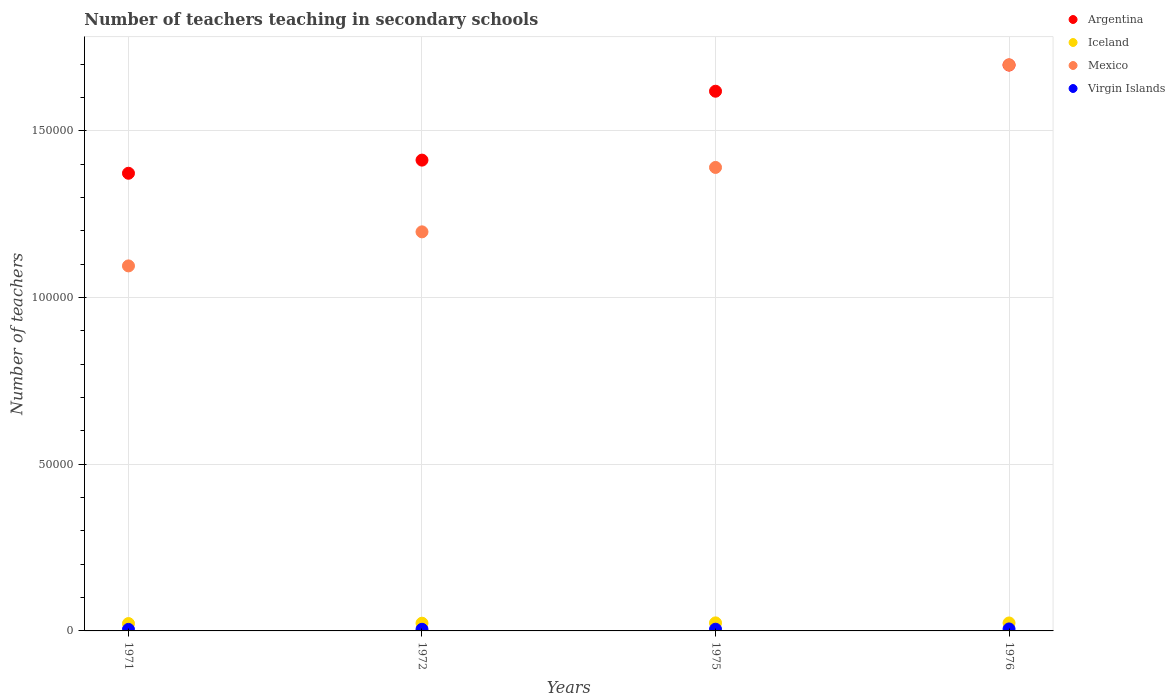Is the number of dotlines equal to the number of legend labels?
Offer a very short reply. Yes. What is the number of teachers teaching in secondary schools in Mexico in 1975?
Make the answer very short. 1.39e+05. Across all years, what is the maximum number of teachers teaching in secondary schools in Mexico?
Offer a very short reply. 1.70e+05. Across all years, what is the minimum number of teachers teaching in secondary schools in Iceland?
Your answer should be very brief. 2207. In which year was the number of teachers teaching in secondary schools in Mexico maximum?
Your answer should be very brief. 1976. What is the total number of teachers teaching in secondary schools in Iceland in the graph?
Your answer should be very brief. 9325. What is the difference between the number of teachers teaching in secondary schools in Iceland in 1972 and that in 1975?
Provide a succinct answer. -95. What is the difference between the number of teachers teaching in secondary schools in Iceland in 1971 and the number of teachers teaching in secondary schools in Virgin Islands in 1972?
Provide a short and direct response. 1720. What is the average number of teachers teaching in secondary schools in Iceland per year?
Your answer should be compact. 2331.25. In the year 1975, what is the difference between the number of teachers teaching in secondary schools in Argentina and number of teachers teaching in secondary schools in Mexico?
Give a very brief answer. 2.29e+04. In how many years, is the number of teachers teaching in secondary schools in Mexico greater than 80000?
Provide a succinct answer. 4. What is the ratio of the number of teachers teaching in secondary schools in Argentina in 1971 to that in 1975?
Offer a terse response. 0.85. Is the number of teachers teaching in secondary schools in Argentina in 1972 less than that in 1975?
Offer a terse response. Yes. Is the difference between the number of teachers teaching in secondary schools in Argentina in 1975 and 1976 greater than the difference between the number of teachers teaching in secondary schools in Mexico in 1975 and 1976?
Your answer should be compact. Yes. What is the difference between the highest and the lowest number of teachers teaching in secondary schools in Virgin Islands?
Your response must be concise. 132. In how many years, is the number of teachers teaching in secondary schools in Mexico greater than the average number of teachers teaching in secondary schools in Mexico taken over all years?
Ensure brevity in your answer.  2. Is the sum of the number of teachers teaching in secondary schools in Argentina in 1971 and 1972 greater than the maximum number of teachers teaching in secondary schools in Iceland across all years?
Make the answer very short. Yes. Is it the case that in every year, the sum of the number of teachers teaching in secondary schools in Argentina and number of teachers teaching in secondary schools in Iceland  is greater than the number of teachers teaching in secondary schools in Virgin Islands?
Your response must be concise. Yes. Does the number of teachers teaching in secondary schools in Argentina monotonically increase over the years?
Keep it short and to the point. Yes. How many dotlines are there?
Your response must be concise. 4. What is the difference between two consecutive major ticks on the Y-axis?
Offer a terse response. 5.00e+04. Are the values on the major ticks of Y-axis written in scientific E-notation?
Ensure brevity in your answer.  No. Does the graph contain any zero values?
Ensure brevity in your answer.  No. What is the title of the graph?
Provide a succinct answer. Number of teachers teaching in secondary schools. Does "Ecuador" appear as one of the legend labels in the graph?
Make the answer very short. No. What is the label or title of the X-axis?
Make the answer very short. Years. What is the label or title of the Y-axis?
Keep it short and to the point. Number of teachers. What is the Number of teachers of Argentina in 1971?
Your answer should be very brief. 1.37e+05. What is the Number of teachers of Iceland in 1971?
Make the answer very short. 2207. What is the Number of teachers in Mexico in 1971?
Your answer should be compact. 1.09e+05. What is the Number of teachers in Virgin Islands in 1971?
Give a very brief answer. 460. What is the Number of teachers of Argentina in 1972?
Offer a terse response. 1.41e+05. What is the Number of teachers in Iceland in 1972?
Ensure brevity in your answer.  2318. What is the Number of teachers in Mexico in 1972?
Offer a terse response. 1.20e+05. What is the Number of teachers in Virgin Islands in 1972?
Make the answer very short. 487. What is the Number of teachers of Argentina in 1975?
Keep it short and to the point. 1.62e+05. What is the Number of teachers in Iceland in 1975?
Give a very brief answer. 2413. What is the Number of teachers in Mexico in 1975?
Your response must be concise. 1.39e+05. What is the Number of teachers in Virgin Islands in 1975?
Your response must be concise. 514. What is the Number of teachers in Argentina in 1976?
Your answer should be compact. 1.70e+05. What is the Number of teachers of Iceland in 1976?
Your response must be concise. 2387. What is the Number of teachers of Mexico in 1976?
Your response must be concise. 1.70e+05. What is the Number of teachers of Virgin Islands in 1976?
Offer a terse response. 592. Across all years, what is the maximum Number of teachers of Argentina?
Make the answer very short. 1.70e+05. Across all years, what is the maximum Number of teachers of Iceland?
Keep it short and to the point. 2413. Across all years, what is the maximum Number of teachers of Mexico?
Ensure brevity in your answer.  1.70e+05. Across all years, what is the maximum Number of teachers in Virgin Islands?
Your response must be concise. 592. Across all years, what is the minimum Number of teachers in Argentina?
Give a very brief answer. 1.37e+05. Across all years, what is the minimum Number of teachers of Iceland?
Make the answer very short. 2207. Across all years, what is the minimum Number of teachers in Mexico?
Make the answer very short. 1.09e+05. Across all years, what is the minimum Number of teachers of Virgin Islands?
Your answer should be compact. 460. What is the total Number of teachers of Argentina in the graph?
Offer a very short reply. 6.10e+05. What is the total Number of teachers of Iceland in the graph?
Ensure brevity in your answer.  9325. What is the total Number of teachers of Mexico in the graph?
Offer a very short reply. 5.38e+05. What is the total Number of teachers in Virgin Islands in the graph?
Your response must be concise. 2053. What is the difference between the Number of teachers in Argentina in 1971 and that in 1972?
Keep it short and to the point. -3941. What is the difference between the Number of teachers in Iceland in 1971 and that in 1972?
Make the answer very short. -111. What is the difference between the Number of teachers in Mexico in 1971 and that in 1972?
Your answer should be compact. -1.02e+04. What is the difference between the Number of teachers in Virgin Islands in 1971 and that in 1972?
Give a very brief answer. -27. What is the difference between the Number of teachers in Argentina in 1971 and that in 1975?
Your answer should be very brief. -2.46e+04. What is the difference between the Number of teachers of Iceland in 1971 and that in 1975?
Keep it short and to the point. -206. What is the difference between the Number of teachers of Mexico in 1971 and that in 1975?
Provide a succinct answer. -2.95e+04. What is the difference between the Number of teachers of Virgin Islands in 1971 and that in 1975?
Your answer should be compact. -54. What is the difference between the Number of teachers in Argentina in 1971 and that in 1976?
Your answer should be compact. -3.24e+04. What is the difference between the Number of teachers in Iceland in 1971 and that in 1976?
Offer a terse response. -180. What is the difference between the Number of teachers of Mexico in 1971 and that in 1976?
Offer a terse response. -6.03e+04. What is the difference between the Number of teachers in Virgin Islands in 1971 and that in 1976?
Ensure brevity in your answer.  -132. What is the difference between the Number of teachers of Argentina in 1972 and that in 1975?
Keep it short and to the point. -2.07e+04. What is the difference between the Number of teachers in Iceland in 1972 and that in 1975?
Your answer should be very brief. -95. What is the difference between the Number of teachers in Mexico in 1972 and that in 1975?
Your answer should be compact. -1.93e+04. What is the difference between the Number of teachers in Virgin Islands in 1972 and that in 1975?
Ensure brevity in your answer.  -27. What is the difference between the Number of teachers in Argentina in 1972 and that in 1976?
Your answer should be compact. -2.85e+04. What is the difference between the Number of teachers of Iceland in 1972 and that in 1976?
Provide a short and direct response. -69. What is the difference between the Number of teachers of Mexico in 1972 and that in 1976?
Make the answer very short. -5.01e+04. What is the difference between the Number of teachers in Virgin Islands in 1972 and that in 1976?
Offer a terse response. -105. What is the difference between the Number of teachers of Argentina in 1975 and that in 1976?
Offer a very short reply. -7845. What is the difference between the Number of teachers in Mexico in 1975 and that in 1976?
Make the answer very short. -3.08e+04. What is the difference between the Number of teachers in Virgin Islands in 1975 and that in 1976?
Make the answer very short. -78. What is the difference between the Number of teachers of Argentina in 1971 and the Number of teachers of Iceland in 1972?
Your response must be concise. 1.35e+05. What is the difference between the Number of teachers of Argentina in 1971 and the Number of teachers of Mexico in 1972?
Your answer should be compact. 1.76e+04. What is the difference between the Number of teachers of Argentina in 1971 and the Number of teachers of Virgin Islands in 1972?
Your answer should be compact. 1.37e+05. What is the difference between the Number of teachers of Iceland in 1971 and the Number of teachers of Mexico in 1972?
Your answer should be very brief. -1.17e+05. What is the difference between the Number of teachers in Iceland in 1971 and the Number of teachers in Virgin Islands in 1972?
Your response must be concise. 1720. What is the difference between the Number of teachers in Mexico in 1971 and the Number of teachers in Virgin Islands in 1972?
Your answer should be compact. 1.09e+05. What is the difference between the Number of teachers in Argentina in 1971 and the Number of teachers in Iceland in 1975?
Your answer should be very brief. 1.35e+05. What is the difference between the Number of teachers in Argentina in 1971 and the Number of teachers in Mexico in 1975?
Offer a very short reply. -1745. What is the difference between the Number of teachers of Argentina in 1971 and the Number of teachers of Virgin Islands in 1975?
Offer a terse response. 1.37e+05. What is the difference between the Number of teachers of Iceland in 1971 and the Number of teachers of Mexico in 1975?
Your answer should be compact. -1.37e+05. What is the difference between the Number of teachers in Iceland in 1971 and the Number of teachers in Virgin Islands in 1975?
Your response must be concise. 1693. What is the difference between the Number of teachers of Mexico in 1971 and the Number of teachers of Virgin Islands in 1975?
Your answer should be compact. 1.09e+05. What is the difference between the Number of teachers of Argentina in 1971 and the Number of teachers of Iceland in 1976?
Provide a succinct answer. 1.35e+05. What is the difference between the Number of teachers of Argentina in 1971 and the Number of teachers of Mexico in 1976?
Your answer should be compact. -3.25e+04. What is the difference between the Number of teachers in Argentina in 1971 and the Number of teachers in Virgin Islands in 1976?
Keep it short and to the point. 1.37e+05. What is the difference between the Number of teachers of Iceland in 1971 and the Number of teachers of Mexico in 1976?
Give a very brief answer. -1.68e+05. What is the difference between the Number of teachers of Iceland in 1971 and the Number of teachers of Virgin Islands in 1976?
Your answer should be compact. 1615. What is the difference between the Number of teachers in Mexico in 1971 and the Number of teachers in Virgin Islands in 1976?
Provide a short and direct response. 1.09e+05. What is the difference between the Number of teachers in Argentina in 1972 and the Number of teachers in Iceland in 1975?
Your answer should be very brief. 1.39e+05. What is the difference between the Number of teachers in Argentina in 1972 and the Number of teachers in Mexico in 1975?
Give a very brief answer. 2196. What is the difference between the Number of teachers in Argentina in 1972 and the Number of teachers in Virgin Islands in 1975?
Your answer should be compact. 1.41e+05. What is the difference between the Number of teachers of Iceland in 1972 and the Number of teachers of Mexico in 1975?
Your answer should be very brief. -1.37e+05. What is the difference between the Number of teachers of Iceland in 1972 and the Number of teachers of Virgin Islands in 1975?
Your response must be concise. 1804. What is the difference between the Number of teachers in Mexico in 1972 and the Number of teachers in Virgin Islands in 1975?
Provide a short and direct response. 1.19e+05. What is the difference between the Number of teachers in Argentina in 1972 and the Number of teachers in Iceland in 1976?
Ensure brevity in your answer.  1.39e+05. What is the difference between the Number of teachers of Argentina in 1972 and the Number of teachers of Mexico in 1976?
Your answer should be very brief. -2.86e+04. What is the difference between the Number of teachers of Argentina in 1972 and the Number of teachers of Virgin Islands in 1976?
Give a very brief answer. 1.41e+05. What is the difference between the Number of teachers in Iceland in 1972 and the Number of teachers in Mexico in 1976?
Offer a terse response. -1.67e+05. What is the difference between the Number of teachers in Iceland in 1972 and the Number of teachers in Virgin Islands in 1976?
Keep it short and to the point. 1726. What is the difference between the Number of teachers of Mexico in 1972 and the Number of teachers of Virgin Islands in 1976?
Provide a short and direct response. 1.19e+05. What is the difference between the Number of teachers in Argentina in 1975 and the Number of teachers in Iceland in 1976?
Make the answer very short. 1.59e+05. What is the difference between the Number of teachers in Argentina in 1975 and the Number of teachers in Mexico in 1976?
Your answer should be very brief. -7922. What is the difference between the Number of teachers of Argentina in 1975 and the Number of teachers of Virgin Islands in 1976?
Keep it short and to the point. 1.61e+05. What is the difference between the Number of teachers of Iceland in 1975 and the Number of teachers of Mexico in 1976?
Provide a short and direct response. -1.67e+05. What is the difference between the Number of teachers in Iceland in 1975 and the Number of teachers in Virgin Islands in 1976?
Ensure brevity in your answer.  1821. What is the difference between the Number of teachers of Mexico in 1975 and the Number of teachers of Virgin Islands in 1976?
Offer a terse response. 1.38e+05. What is the average Number of teachers of Argentina per year?
Offer a very short reply. 1.53e+05. What is the average Number of teachers in Iceland per year?
Provide a succinct answer. 2331.25. What is the average Number of teachers in Mexico per year?
Keep it short and to the point. 1.34e+05. What is the average Number of teachers of Virgin Islands per year?
Provide a succinct answer. 513.25. In the year 1971, what is the difference between the Number of teachers in Argentina and Number of teachers in Iceland?
Provide a succinct answer. 1.35e+05. In the year 1971, what is the difference between the Number of teachers in Argentina and Number of teachers in Mexico?
Make the answer very short. 2.78e+04. In the year 1971, what is the difference between the Number of teachers in Argentina and Number of teachers in Virgin Islands?
Your answer should be compact. 1.37e+05. In the year 1971, what is the difference between the Number of teachers of Iceland and Number of teachers of Mexico?
Keep it short and to the point. -1.07e+05. In the year 1971, what is the difference between the Number of teachers in Iceland and Number of teachers in Virgin Islands?
Your response must be concise. 1747. In the year 1971, what is the difference between the Number of teachers in Mexico and Number of teachers in Virgin Islands?
Keep it short and to the point. 1.09e+05. In the year 1972, what is the difference between the Number of teachers of Argentina and Number of teachers of Iceland?
Provide a succinct answer. 1.39e+05. In the year 1972, what is the difference between the Number of teachers of Argentina and Number of teachers of Mexico?
Offer a terse response. 2.15e+04. In the year 1972, what is the difference between the Number of teachers of Argentina and Number of teachers of Virgin Islands?
Your answer should be compact. 1.41e+05. In the year 1972, what is the difference between the Number of teachers of Iceland and Number of teachers of Mexico?
Your answer should be compact. -1.17e+05. In the year 1972, what is the difference between the Number of teachers in Iceland and Number of teachers in Virgin Islands?
Make the answer very short. 1831. In the year 1972, what is the difference between the Number of teachers of Mexico and Number of teachers of Virgin Islands?
Offer a terse response. 1.19e+05. In the year 1975, what is the difference between the Number of teachers in Argentina and Number of teachers in Iceland?
Ensure brevity in your answer.  1.59e+05. In the year 1975, what is the difference between the Number of teachers in Argentina and Number of teachers in Mexico?
Make the answer very short. 2.29e+04. In the year 1975, what is the difference between the Number of teachers of Argentina and Number of teachers of Virgin Islands?
Provide a short and direct response. 1.61e+05. In the year 1975, what is the difference between the Number of teachers in Iceland and Number of teachers in Mexico?
Offer a terse response. -1.37e+05. In the year 1975, what is the difference between the Number of teachers of Iceland and Number of teachers of Virgin Islands?
Your answer should be compact. 1899. In the year 1975, what is the difference between the Number of teachers of Mexico and Number of teachers of Virgin Islands?
Make the answer very short. 1.38e+05. In the year 1976, what is the difference between the Number of teachers of Argentina and Number of teachers of Iceland?
Make the answer very short. 1.67e+05. In the year 1976, what is the difference between the Number of teachers in Argentina and Number of teachers in Mexico?
Make the answer very short. -77. In the year 1976, what is the difference between the Number of teachers of Argentina and Number of teachers of Virgin Islands?
Your answer should be very brief. 1.69e+05. In the year 1976, what is the difference between the Number of teachers of Iceland and Number of teachers of Mexico?
Your response must be concise. -1.67e+05. In the year 1976, what is the difference between the Number of teachers of Iceland and Number of teachers of Virgin Islands?
Offer a terse response. 1795. In the year 1976, what is the difference between the Number of teachers of Mexico and Number of teachers of Virgin Islands?
Give a very brief answer. 1.69e+05. What is the ratio of the Number of teachers in Argentina in 1971 to that in 1972?
Your answer should be very brief. 0.97. What is the ratio of the Number of teachers of Iceland in 1971 to that in 1972?
Provide a succinct answer. 0.95. What is the ratio of the Number of teachers of Mexico in 1971 to that in 1972?
Provide a succinct answer. 0.91. What is the ratio of the Number of teachers in Virgin Islands in 1971 to that in 1972?
Your answer should be compact. 0.94. What is the ratio of the Number of teachers in Argentina in 1971 to that in 1975?
Your answer should be compact. 0.85. What is the ratio of the Number of teachers of Iceland in 1971 to that in 1975?
Your answer should be very brief. 0.91. What is the ratio of the Number of teachers of Mexico in 1971 to that in 1975?
Your response must be concise. 0.79. What is the ratio of the Number of teachers of Virgin Islands in 1971 to that in 1975?
Keep it short and to the point. 0.89. What is the ratio of the Number of teachers of Argentina in 1971 to that in 1976?
Your response must be concise. 0.81. What is the ratio of the Number of teachers of Iceland in 1971 to that in 1976?
Provide a succinct answer. 0.92. What is the ratio of the Number of teachers in Mexico in 1971 to that in 1976?
Make the answer very short. 0.64. What is the ratio of the Number of teachers in Virgin Islands in 1971 to that in 1976?
Offer a terse response. 0.78. What is the ratio of the Number of teachers of Argentina in 1972 to that in 1975?
Your answer should be very brief. 0.87. What is the ratio of the Number of teachers of Iceland in 1972 to that in 1975?
Offer a very short reply. 0.96. What is the ratio of the Number of teachers of Mexico in 1972 to that in 1975?
Give a very brief answer. 0.86. What is the ratio of the Number of teachers in Virgin Islands in 1972 to that in 1975?
Your answer should be very brief. 0.95. What is the ratio of the Number of teachers in Argentina in 1972 to that in 1976?
Keep it short and to the point. 0.83. What is the ratio of the Number of teachers in Iceland in 1972 to that in 1976?
Ensure brevity in your answer.  0.97. What is the ratio of the Number of teachers in Mexico in 1972 to that in 1976?
Make the answer very short. 0.7. What is the ratio of the Number of teachers of Virgin Islands in 1972 to that in 1976?
Keep it short and to the point. 0.82. What is the ratio of the Number of teachers in Argentina in 1975 to that in 1976?
Your answer should be very brief. 0.95. What is the ratio of the Number of teachers of Iceland in 1975 to that in 1976?
Keep it short and to the point. 1.01. What is the ratio of the Number of teachers of Mexico in 1975 to that in 1976?
Make the answer very short. 0.82. What is the ratio of the Number of teachers of Virgin Islands in 1975 to that in 1976?
Your answer should be very brief. 0.87. What is the difference between the highest and the second highest Number of teachers of Argentina?
Your response must be concise. 7845. What is the difference between the highest and the second highest Number of teachers in Mexico?
Keep it short and to the point. 3.08e+04. What is the difference between the highest and the lowest Number of teachers in Argentina?
Provide a succinct answer. 3.24e+04. What is the difference between the highest and the lowest Number of teachers of Iceland?
Offer a very short reply. 206. What is the difference between the highest and the lowest Number of teachers of Mexico?
Your answer should be compact. 6.03e+04. What is the difference between the highest and the lowest Number of teachers in Virgin Islands?
Offer a terse response. 132. 